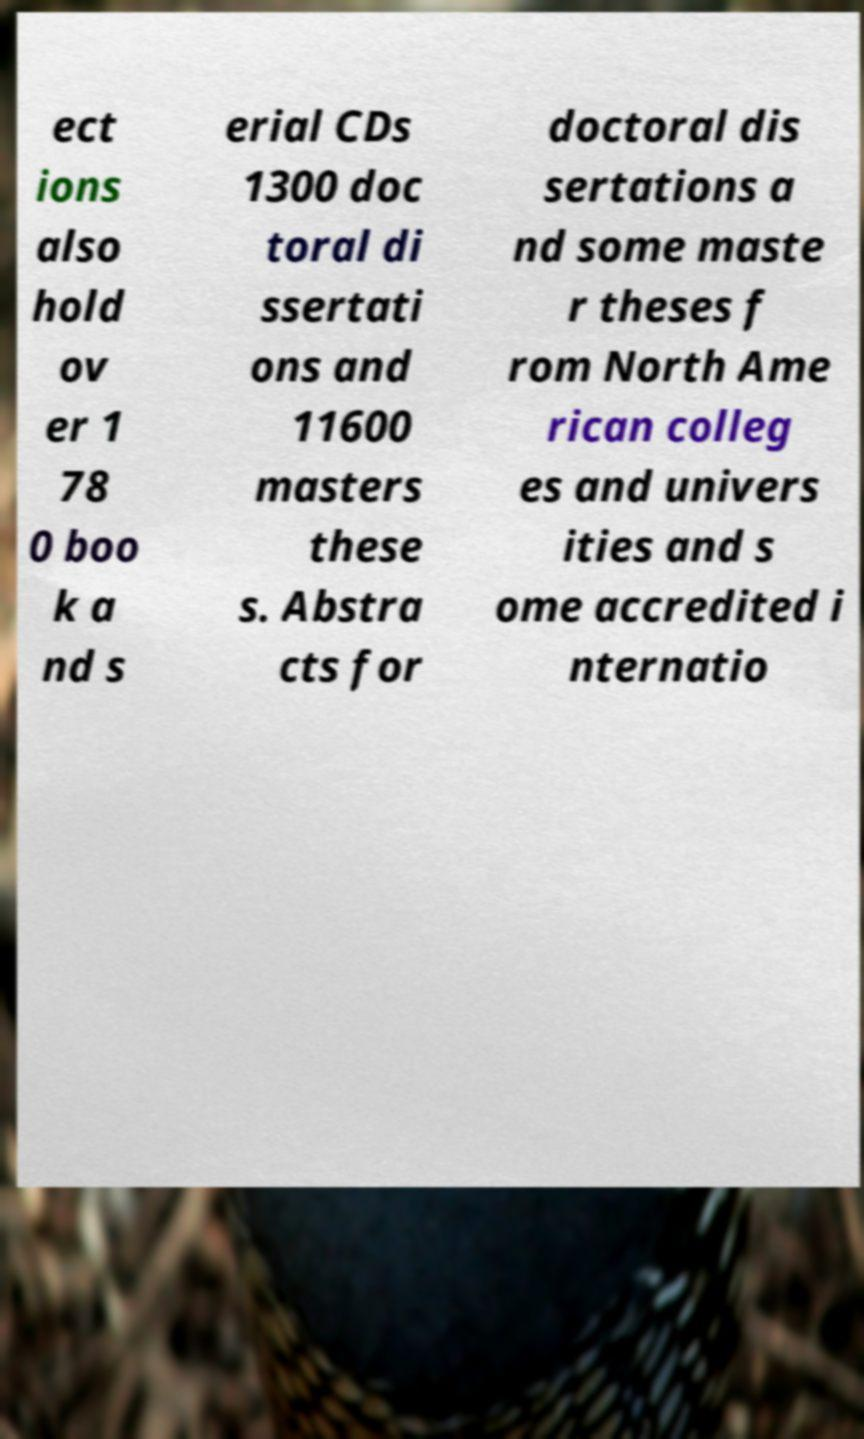Please identify and transcribe the text found in this image. ect ions also hold ov er 1 78 0 boo k a nd s erial CDs 1300 doc toral di ssertati ons and 11600 masters these s. Abstra cts for doctoral dis sertations a nd some maste r theses f rom North Ame rican colleg es and univers ities and s ome accredited i nternatio 